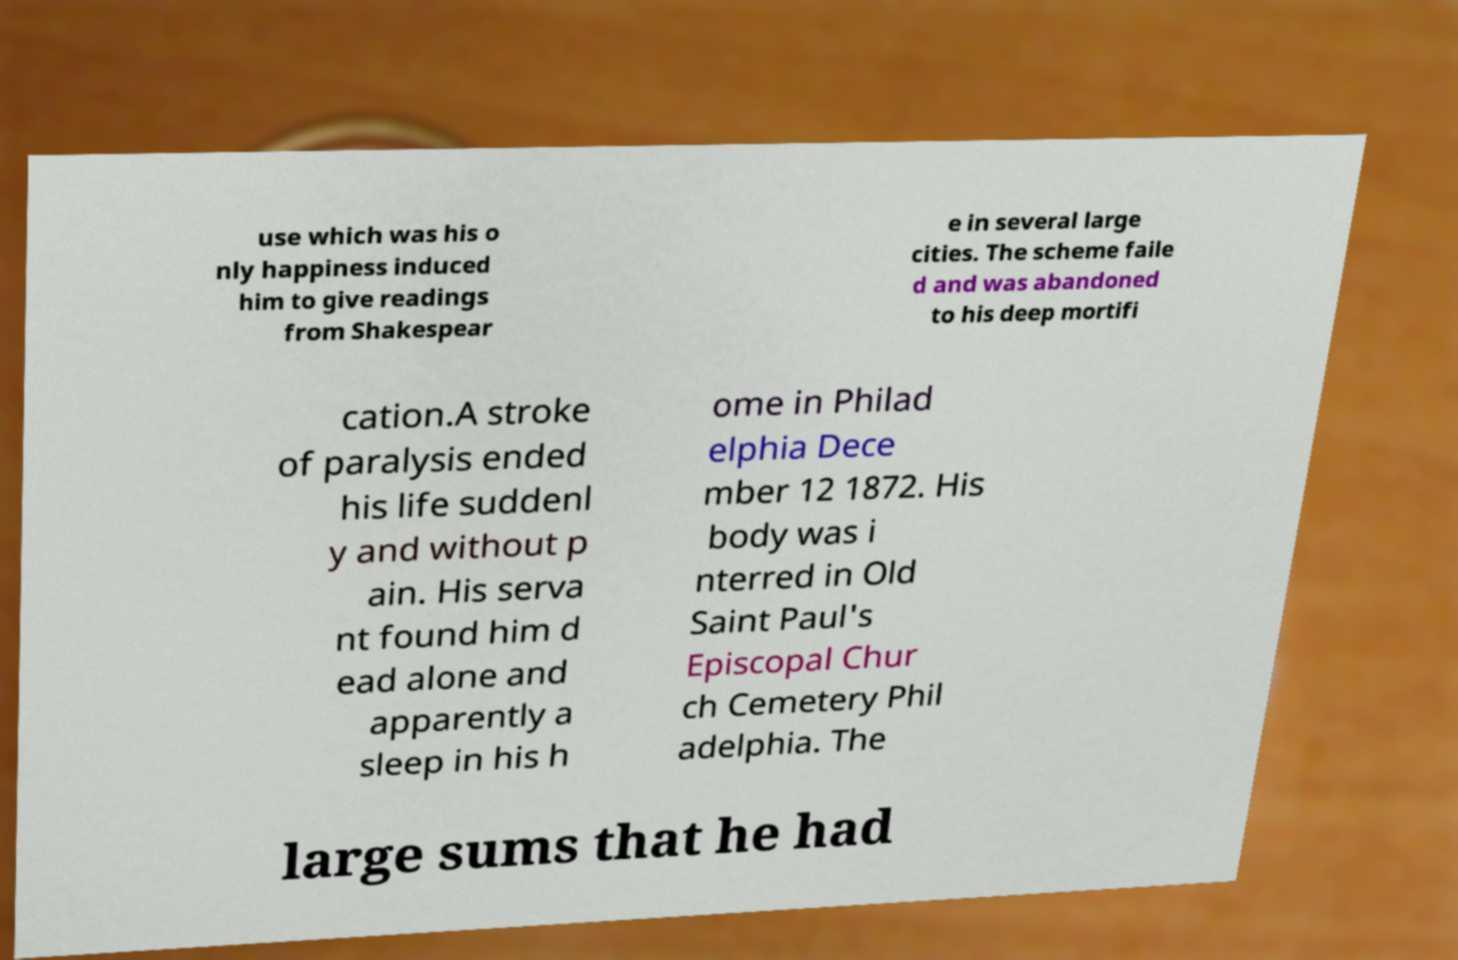Please identify and transcribe the text found in this image. use which was his o nly happiness induced him to give readings from Shakespear e in several large cities. The scheme faile d and was abandoned to his deep mortifi cation.A stroke of paralysis ended his life suddenl y and without p ain. His serva nt found him d ead alone and apparently a sleep in his h ome in Philad elphia Dece mber 12 1872. His body was i nterred in Old Saint Paul's Episcopal Chur ch Cemetery Phil adelphia. The large sums that he had 